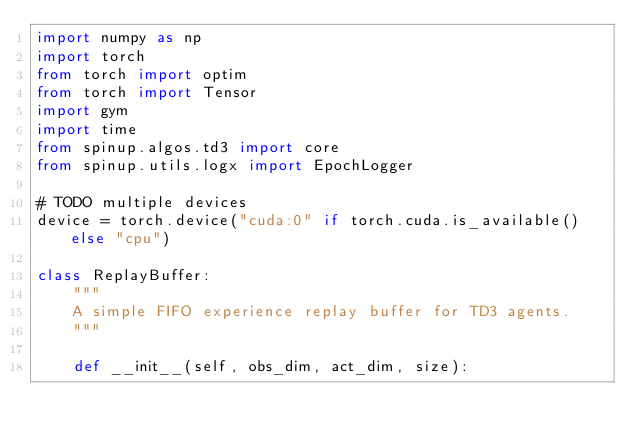Convert code to text. <code><loc_0><loc_0><loc_500><loc_500><_Python_>import numpy as np
import torch
from torch import optim
from torch import Tensor
import gym
import time
from spinup.algos.td3 import core
from spinup.utils.logx import EpochLogger

# TODO multiple devices
device = torch.device("cuda:0" if torch.cuda.is_available() else "cpu")

class ReplayBuffer:
    """
    A simple FIFO experience replay buffer for TD3 agents.
    """

    def __init__(self, obs_dim, act_dim, size):</code> 